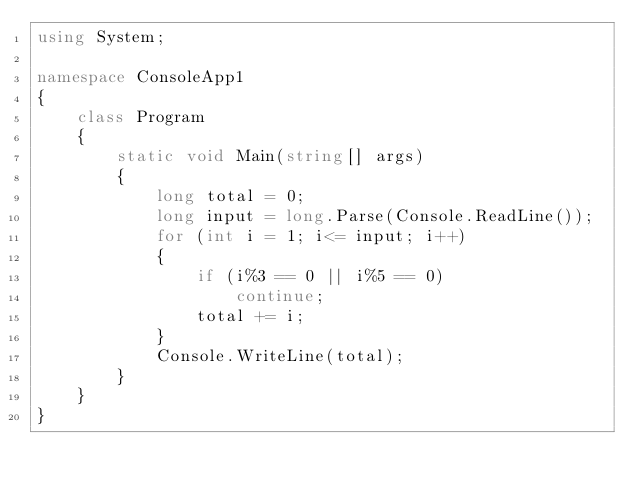Convert code to text. <code><loc_0><loc_0><loc_500><loc_500><_C#_>using System;

namespace ConsoleApp1
{
    class Program
    {
        static void Main(string[] args)
        {
            long total = 0;
            long input = long.Parse(Console.ReadLine());
            for (int i = 1; i<= input; i++)
            {
                if (i%3 == 0 || i%5 == 0)
                    continue;
                total += i;
            }
            Console.WriteLine(total);
        }
    }
}
</code> 